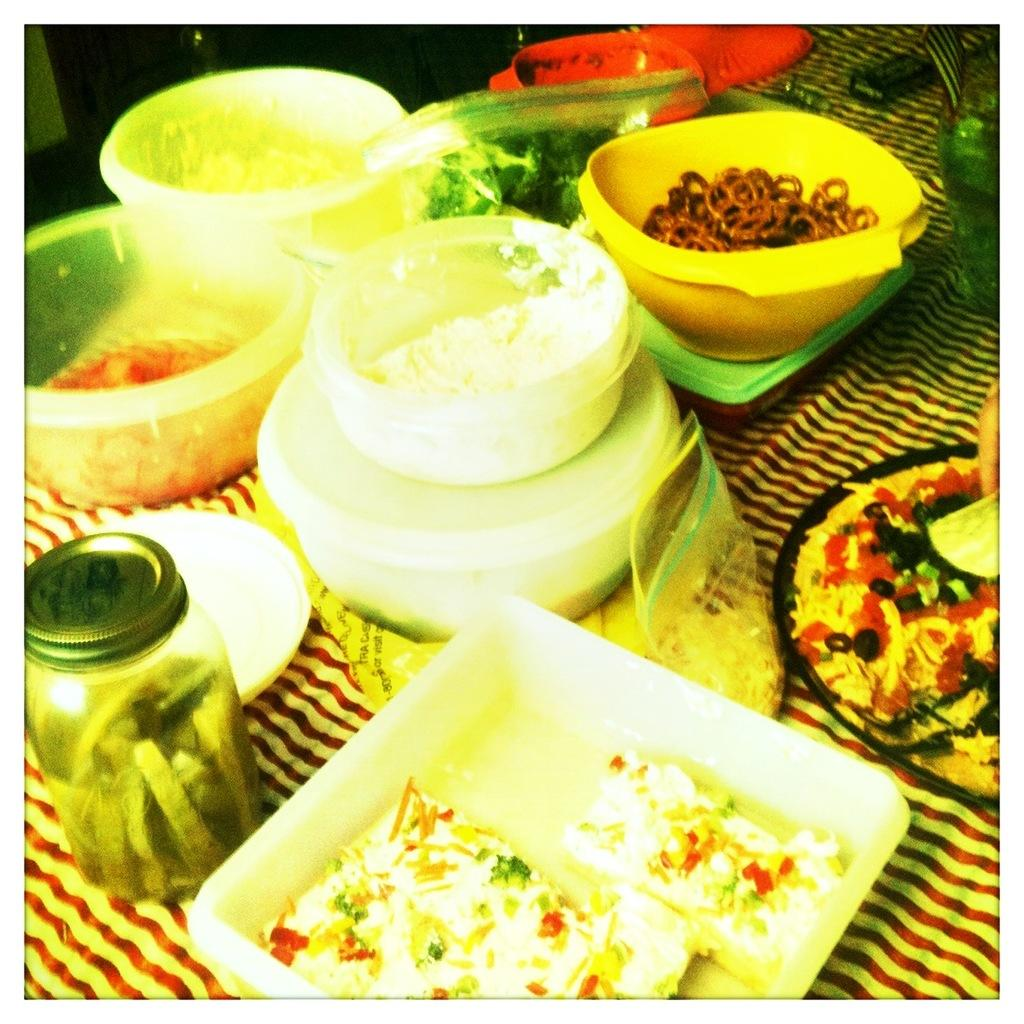What is on the table in the image? There is a bottle and bowls on the table. What is inside the bowls? Food is present in the bowls. Are there any other items on the table besides the bottle and bowls? Yes, there are other things on the table. What is the chance of winning a prize in the image? There is no indication of a prize or a chance to win in the image; it features a table with a bottle, bowls, and other items. How many friends are present in the image? There is no mention of friends or people in the image; it only shows a table with various objects. 